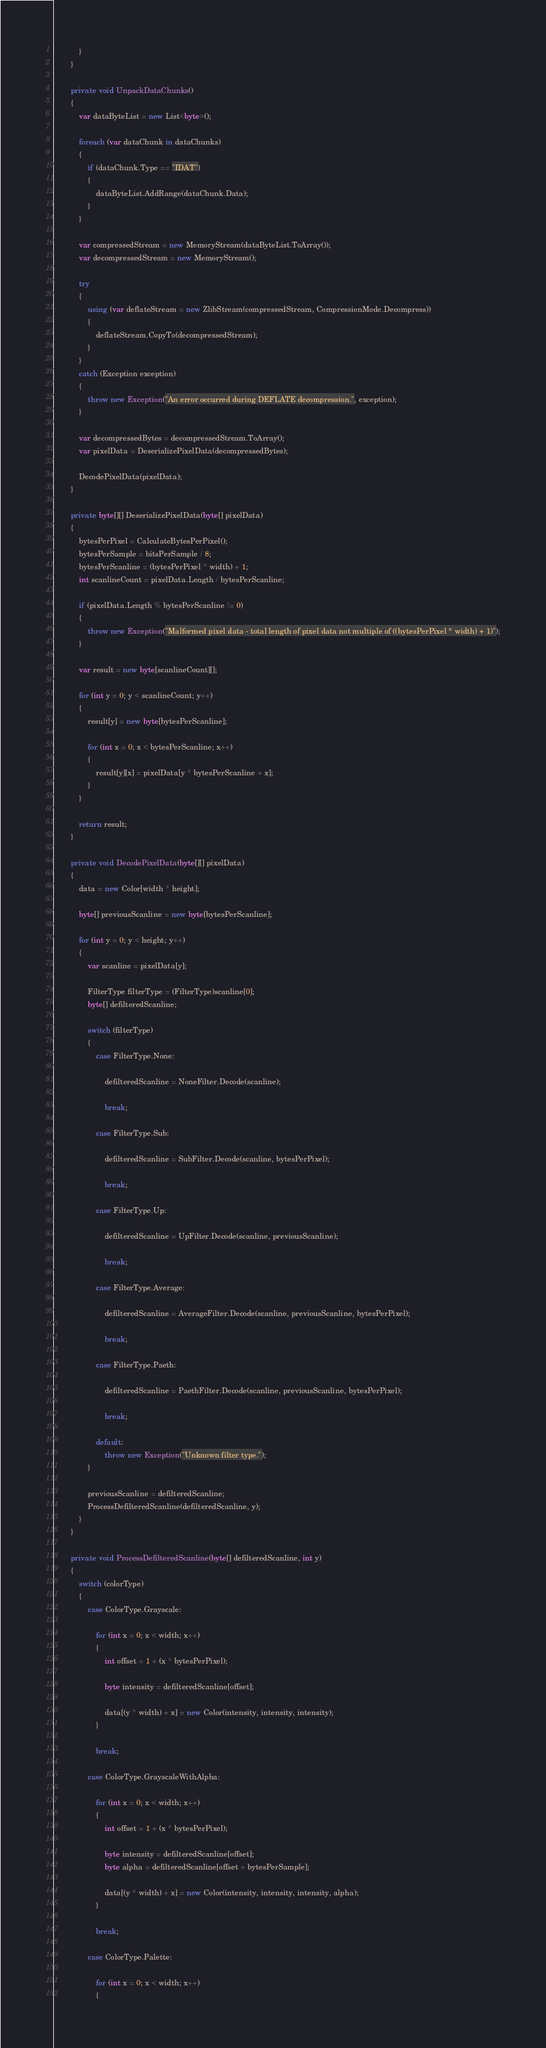<code> <loc_0><loc_0><loc_500><loc_500><_C#_>            }
        }

        private void UnpackDataChunks()
        {
            var dataByteList = new List<byte>();

            foreach (var dataChunk in dataChunks)
            {
                if (dataChunk.Type == "IDAT")
                {
                    dataByteList.AddRange(dataChunk.Data);
                }
            }

            var compressedStream = new MemoryStream(dataByteList.ToArray());
            var decompressedStream = new MemoryStream();

            try
            {
                using (var deflateStream = new ZlibStream(compressedStream, CompressionMode.Decompress))
                {
                    deflateStream.CopyTo(decompressedStream);
                }
            }
            catch (Exception exception)
            {
                throw new Exception("An error occurred during DEFLATE decompression.", exception);
            }

            var decompressedBytes = decompressedStream.ToArray();
            var pixelData = DeserializePixelData(decompressedBytes);

            DecodePixelData(pixelData);
        }

        private byte[][] DeserializePixelData(byte[] pixelData)
        {
            bytesPerPixel = CalculateBytesPerPixel();
            bytesPerSample = bitsPerSample / 8;
            bytesPerScanline = (bytesPerPixel * width) + 1;
            int scanlineCount = pixelData.Length / bytesPerScanline;

            if (pixelData.Length % bytesPerScanline != 0)
            {
                throw new Exception("Malformed pixel data - total length of pixel data not multiple of ((bytesPerPixel * width) + 1)");
            }

            var result = new byte[scanlineCount][];

            for (int y = 0; y < scanlineCount; y++)
            {
                result[y] = new byte[bytesPerScanline];
                
                for (int x = 0; x < bytesPerScanline; x++)
                {
                    result[y][x] = pixelData[y * bytesPerScanline + x];
                }
            }
            
            return result;
        }

        private void DecodePixelData(byte[][] pixelData)
        {
            data = new Color[width * height];
            
            byte[] previousScanline = new byte[bytesPerScanline];

            for (int y = 0; y < height; y++)
            {
                var scanline = pixelData[y];

                FilterType filterType = (FilterType)scanline[0];
                byte[] defilteredScanline;

                switch (filterType)
                {
                    case FilterType.None:

                        defilteredScanline = NoneFilter.Decode(scanline);

                        break;

                    case FilterType.Sub:

                        defilteredScanline = SubFilter.Decode(scanline, bytesPerPixel);

                        break;

                    case FilterType.Up:

                        defilteredScanline = UpFilter.Decode(scanline, previousScanline);

                        break;

                    case FilterType.Average:

                        defilteredScanline = AverageFilter.Decode(scanline, previousScanline, bytesPerPixel);

                        break;

                    case FilterType.Paeth:

                        defilteredScanline = PaethFilter.Decode(scanline, previousScanline, bytesPerPixel);

                        break;

                    default:
                        throw new Exception("Unknown filter type.");
                }

                previousScanline = defilteredScanline;
                ProcessDefilteredScanline(defilteredScanline, y);
            }
        }

        private void ProcessDefilteredScanline(byte[] defilteredScanline, int y)
        {
            switch (colorType)
            {
                case ColorType.Grayscale:

                    for (int x = 0; x < width; x++)
                    {
                        int offset = 1 + (x * bytesPerPixel);

                        byte intensity = defilteredScanline[offset];

                        data[(y * width) + x] = new Color(intensity, intensity, intensity);
                    }

                    break;

                case ColorType.GrayscaleWithAlpha:

                    for (int x = 0; x < width; x++)
                    {
                        int offset = 1 + (x * bytesPerPixel);

                        byte intensity = defilteredScanline[offset];
                        byte alpha = defilteredScanline[offset + bytesPerSample];

                        data[(y * width) + x] = new Color(intensity, intensity, intensity, alpha);
                    }

                    break;

                case ColorType.Palette:

                    for (int x = 0; x < width; x++)
                    {</code> 